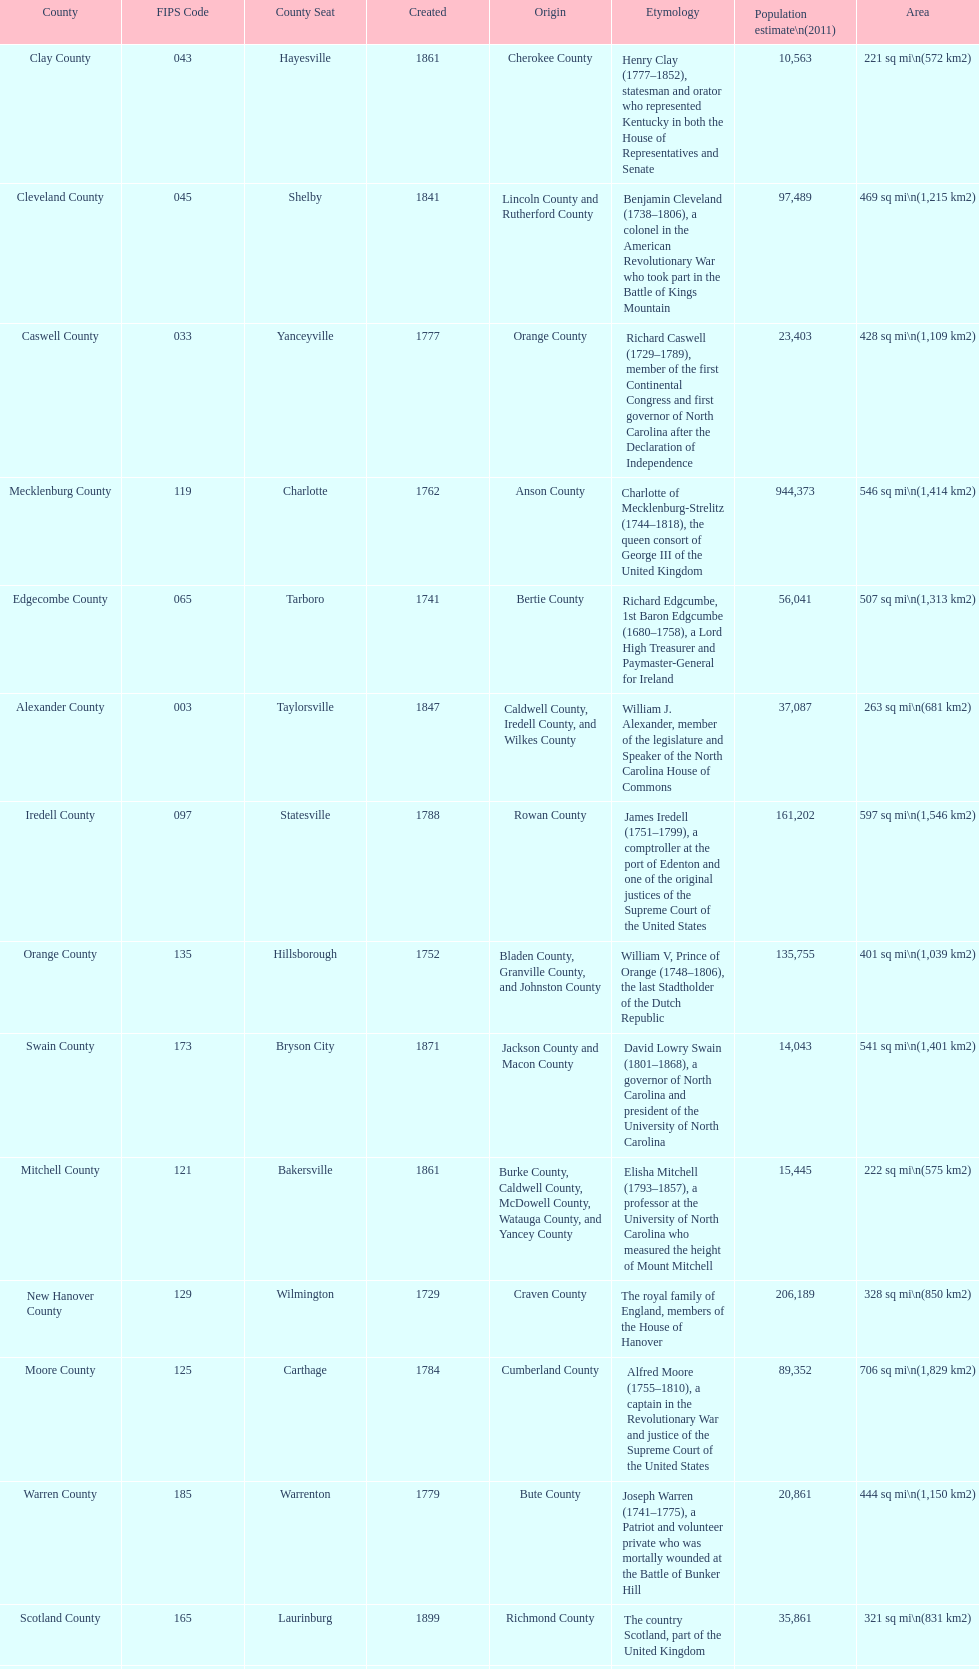Which county has a higher population, alamance or alexander? Alamance County. 